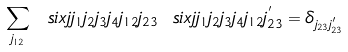<formula> <loc_0><loc_0><loc_500><loc_500>\sum _ { j _ { 1 2 } } \ s i x j { j _ { 1 } } { j _ { 2 } } { j _ { 3 } } { j _ { 4 } } { j _ { 1 2 } } { j _ { 2 3 } } \ s i x j { j _ { 1 } } { j _ { 2 } } { j _ { 3 } } { j _ { 4 } } { j _ { 1 2 } } { j ^ { ^ { \prime } } _ { 2 3 } } = \delta _ { j _ { 2 3 } j ^ { ^ { \prime } } _ { 2 3 } }</formula> 